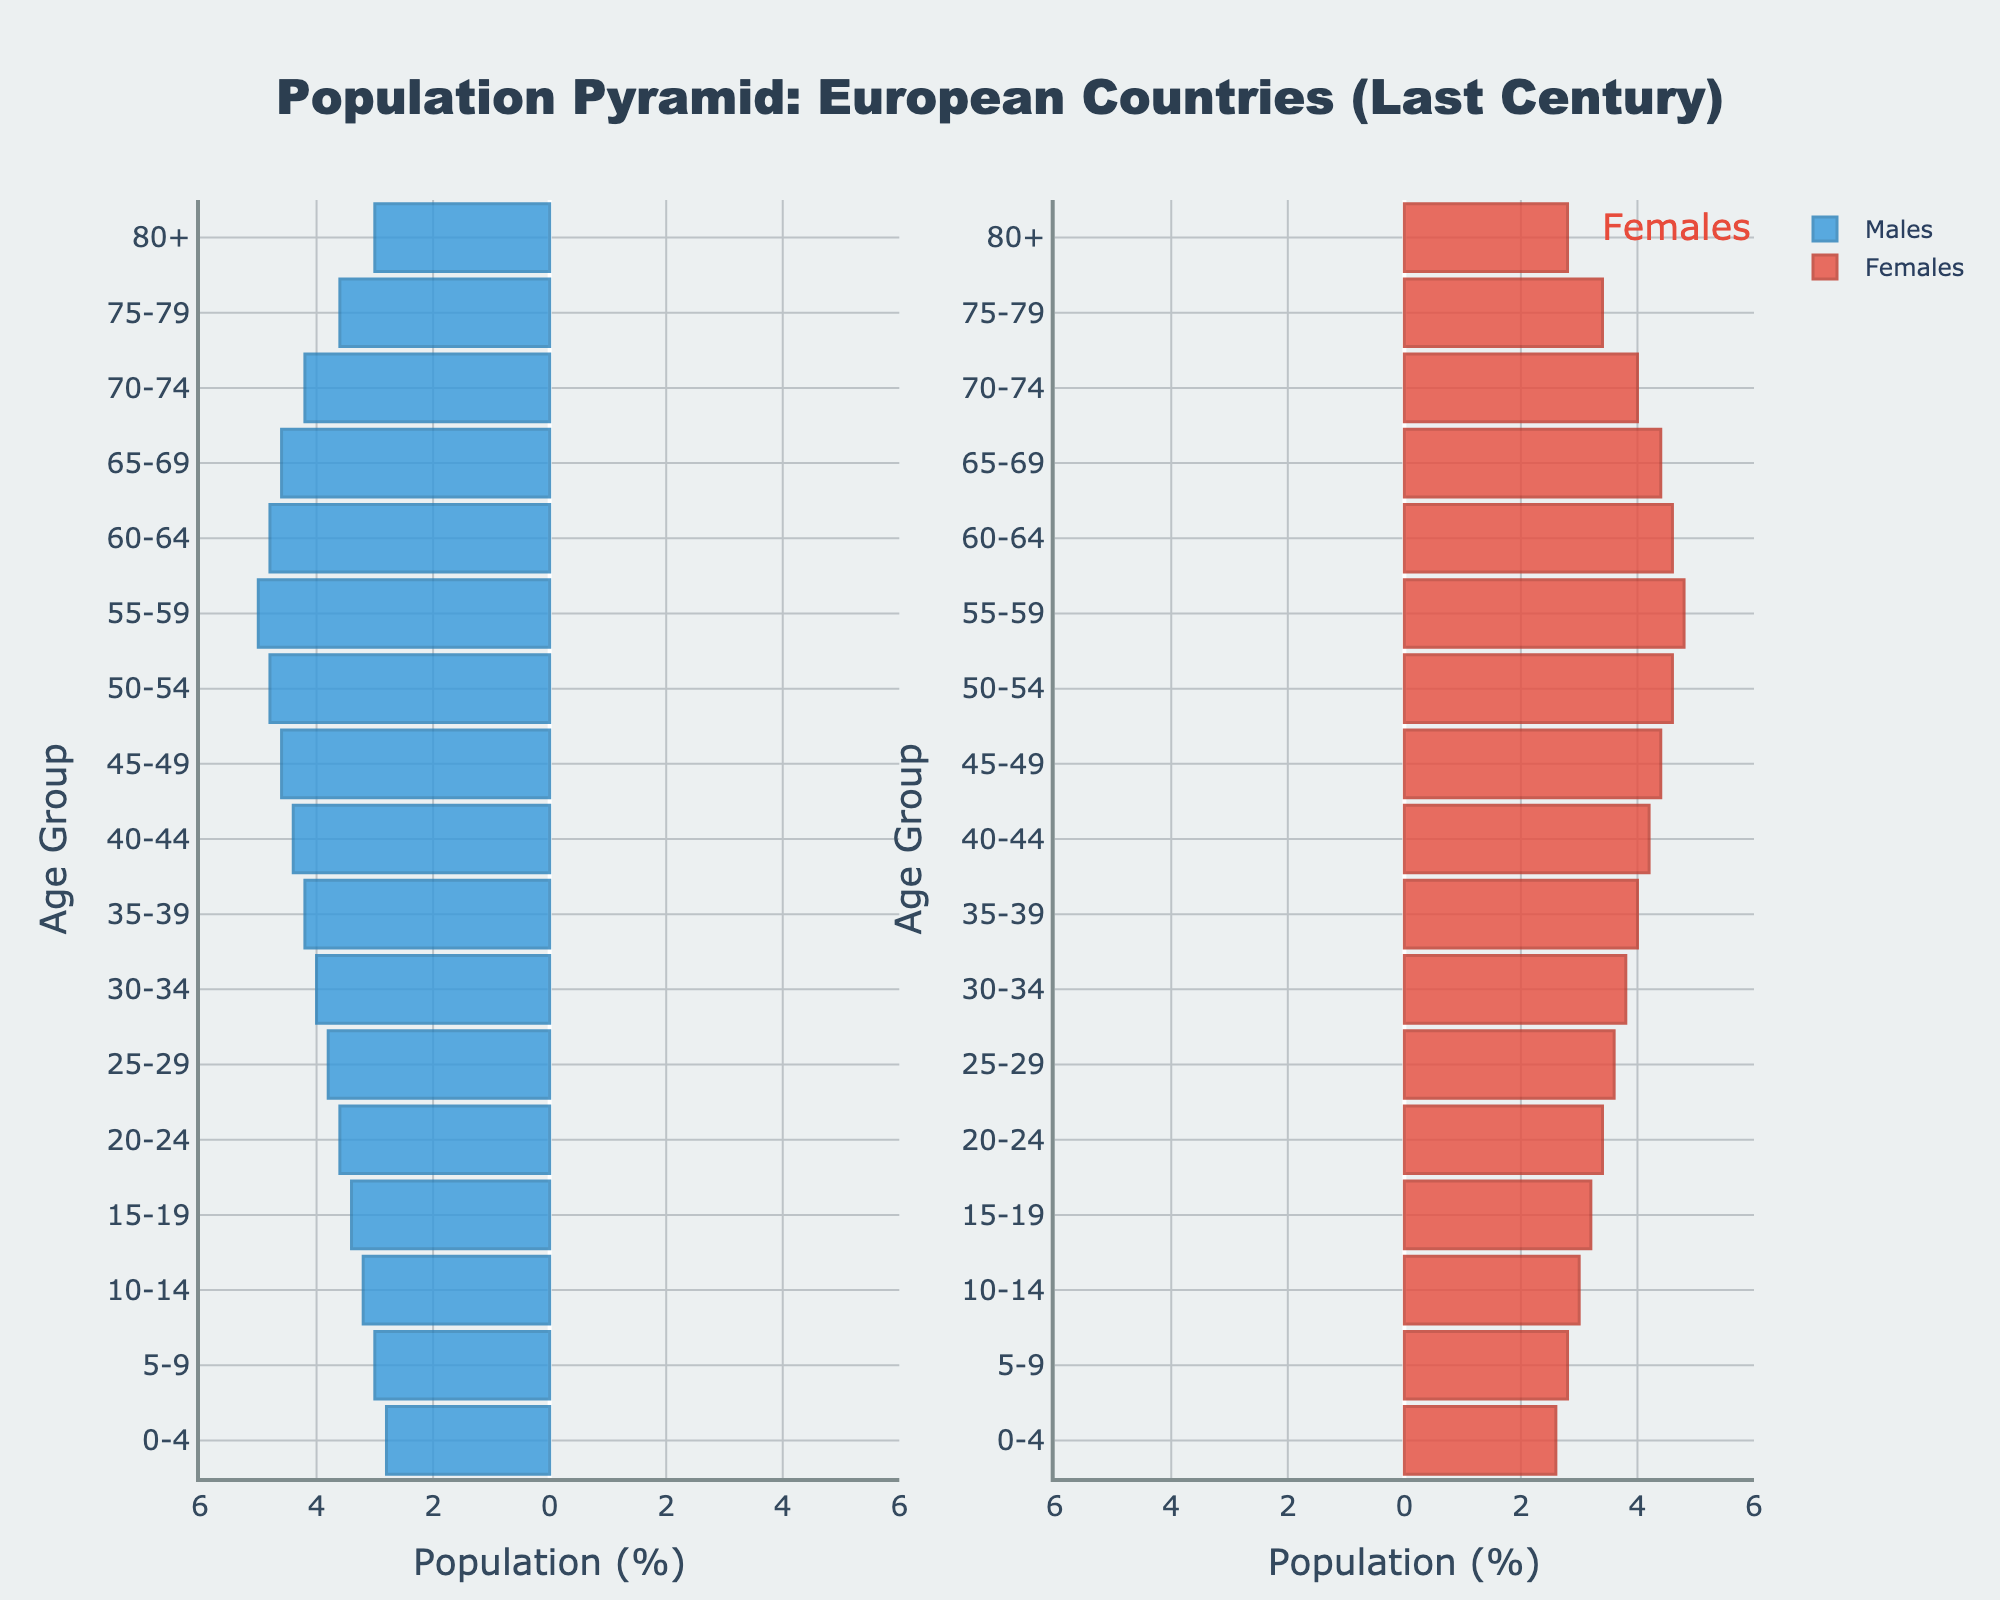What is the title of the population pyramid? The title of the figure is displayed at the top center. It reads "Population Pyramid: European Countries (Last Century)".
Answer: Population Pyramid: European Countries (Last Century) What age group has the highest male population percentage? By examining the left side of the population pyramid (blue bars), the age group 55-59 years has the longest bar, indicating the highest male population percentage.
Answer: 55-59 What age group has the highest female population percentage? By examining the right side of the population pyramid (red bars), the age group 55-59 years has the longest bar, indicating the highest female population percentage.
Answer: 55-59 Which gender has a higher population in the 80+ age group? In the 80+ age group, the red bar (females) is longer than the blue bar (males), indicating a higher female population percentage.
Answer: Females What is the population percentage difference between males and females in the age group 45-49? The population percentage for males in the 45-49 age group is 4.6% and for females it is 4.4%. The difference is
Answer: 0.2% Which age group has a more significant difference between male and female population percentages? By analyzing the gaps between the blue and red bars across all age groups, the age group 55-59 stands out with males at 5.0% and females at 4.8%, making a difference of
Answer: 0.2% How does the population of males and females trend as age increases beyond 60? For age groups 60-64 and older, the width of both blue and red bars declines gradually, showing a decreasing trend in both male and female populations as age increases.
Answer: Declining What does the narrower bar width in the younger age groups (0-4 to 19-24) indicate about recent family sizes? The narrower bars in these age groups suggest smaller family sizes or lower birth rates in recent generations compared to older age groups.
Answer: Smaller family sizes or lower birth rates Comparing the age groups 30-34 and 40-44, which one has a higher male population percentage? The bar for males in the 30-34 age group reaches 4.0%, whereas for the 40-44 age group it is 4.4%. Thus, the 40-44 age group has a higher male population percentage.
Answer: 40-44 